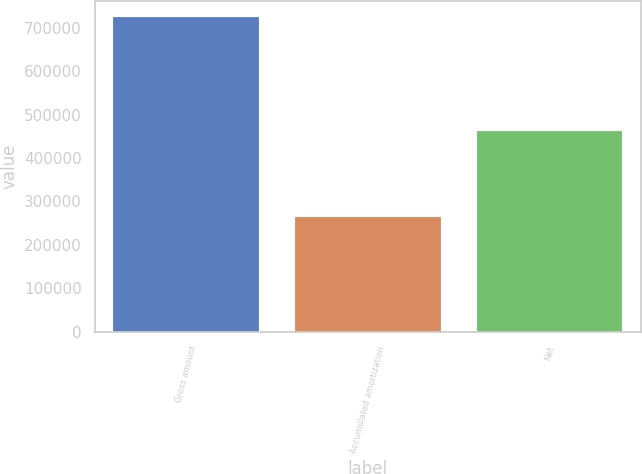Convert chart. <chart><loc_0><loc_0><loc_500><loc_500><bar_chart><fcel>Gross amount<fcel>Accumulated amortization<fcel>Net<nl><fcel>725861<fcel>263107<fcel>462754<nl></chart> 